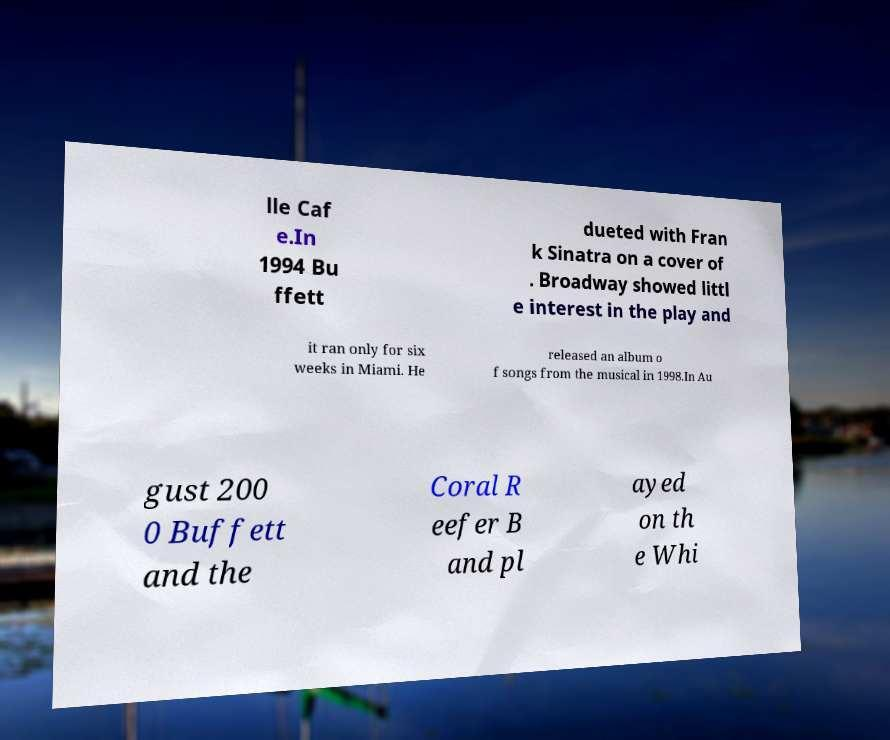Could you extract and type out the text from this image? lle Caf e.In 1994 Bu ffett dueted with Fran k Sinatra on a cover of . Broadway showed littl e interest in the play and it ran only for six weeks in Miami. He released an album o f songs from the musical in 1998.In Au gust 200 0 Buffett and the Coral R eefer B and pl ayed on th e Whi 